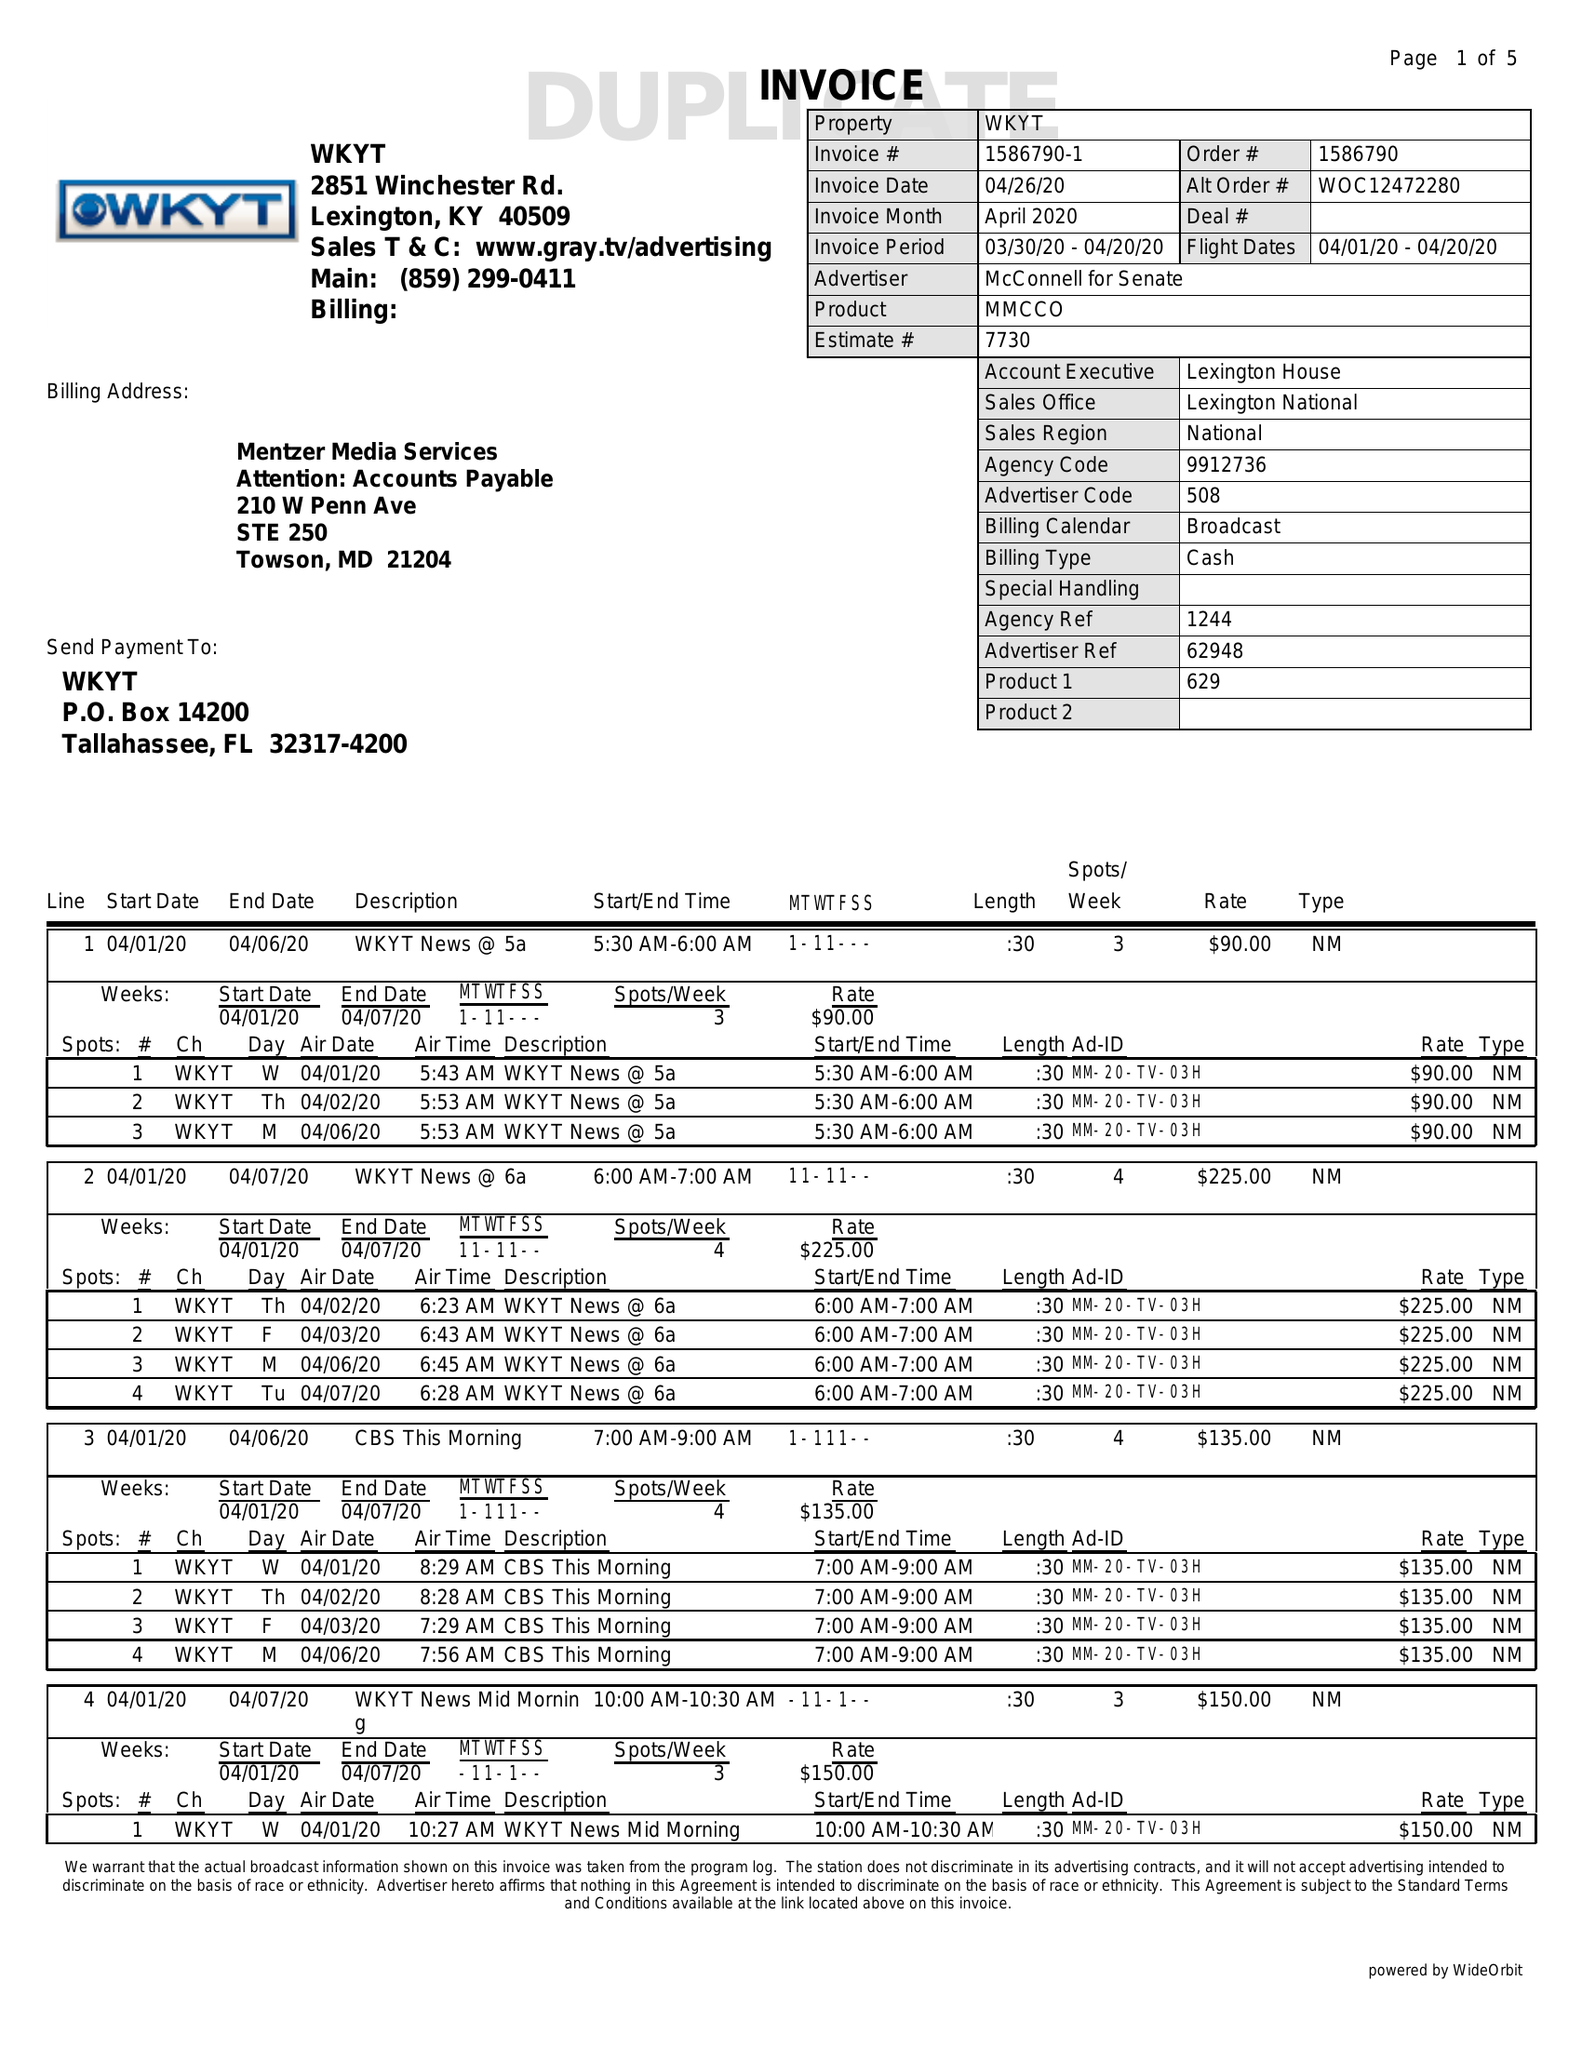What is the value for the flight_from?
Answer the question using a single word or phrase. 04/01/20 